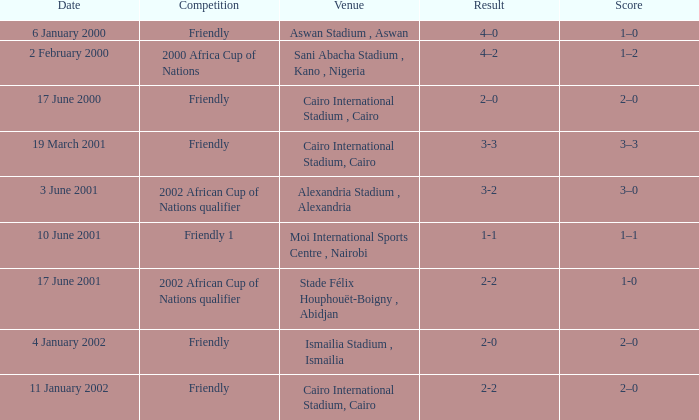What is the score of the match with a 3-2 result? 3–0. 